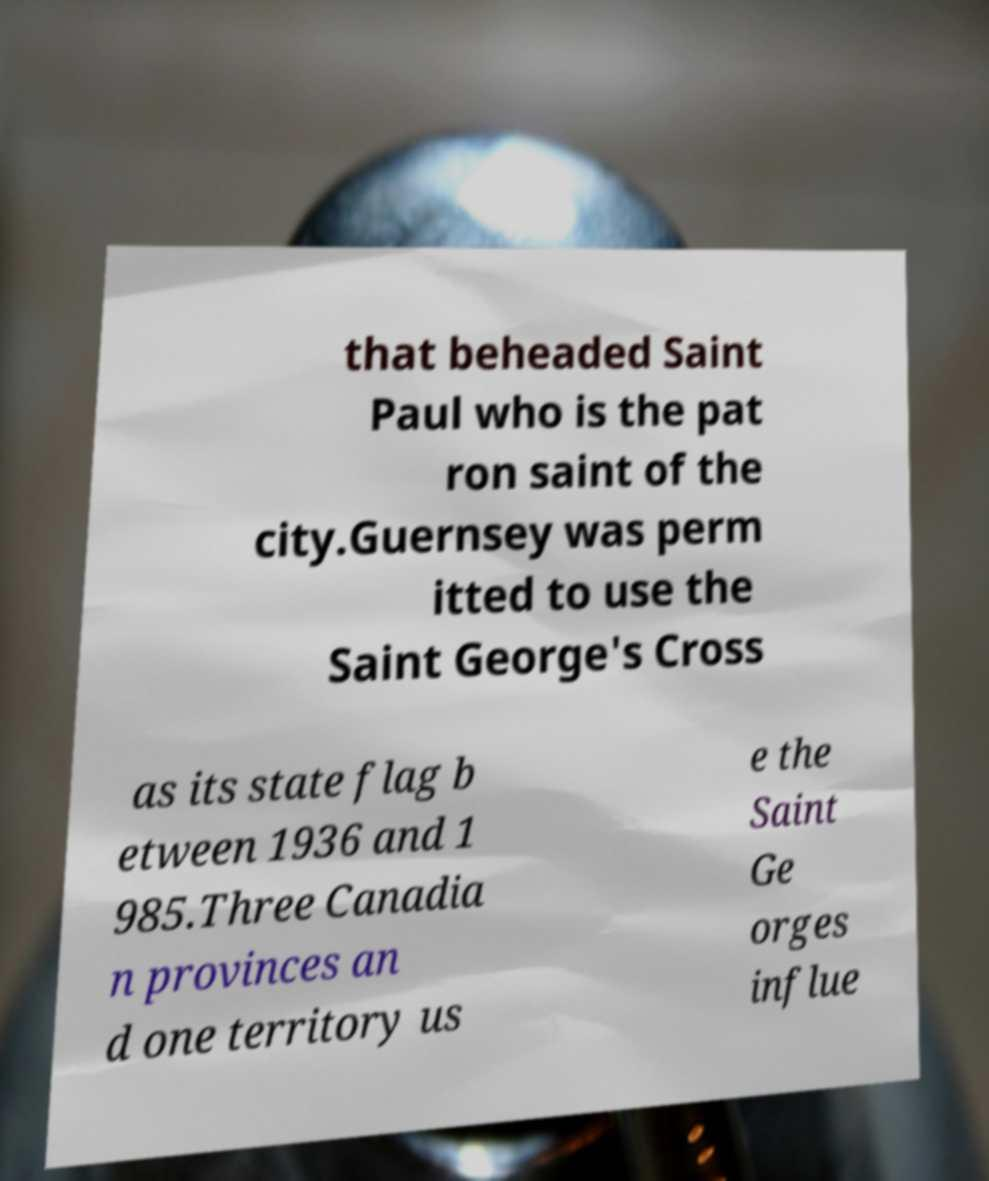Please read and relay the text visible in this image. What does it say? that beheaded Saint Paul who is the pat ron saint of the city.Guernsey was perm itted to use the Saint George's Cross as its state flag b etween 1936 and 1 985.Three Canadia n provinces an d one territory us e the Saint Ge orges influe 